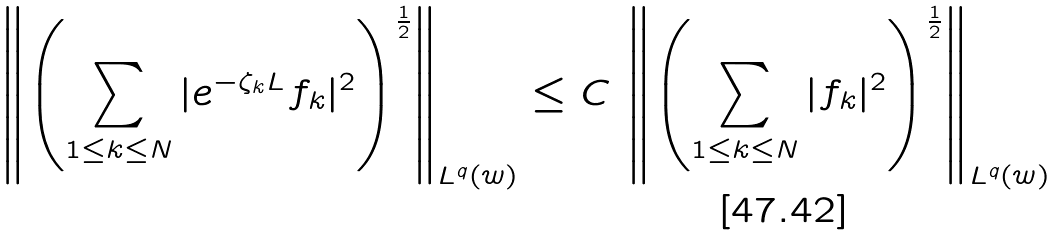Convert formula to latex. <formula><loc_0><loc_0><loc_500><loc_500>\left \| \left ( \sum _ { 1 \leq k \leq N } | e ^ { - \zeta _ { k } L } f _ { k } | ^ { 2 } \right ) ^ { \frac { 1 } { 2 } } \right \| _ { L ^ { q } ( w ) } \leq C \, \left \| \left ( \sum _ { 1 \leq k \leq N } | f _ { k } | ^ { 2 } \right ) ^ { \frac { 1 } { 2 } } \right \| _ { L ^ { q } ( w ) }</formula> 